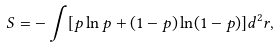<formula> <loc_0><loc_0><loc_500><loc_500>S = - \int [ p \ln p + ( 1 - p ) \ln ( 1 - p ) ] d ^ { 2 } { r } ,</formula> 